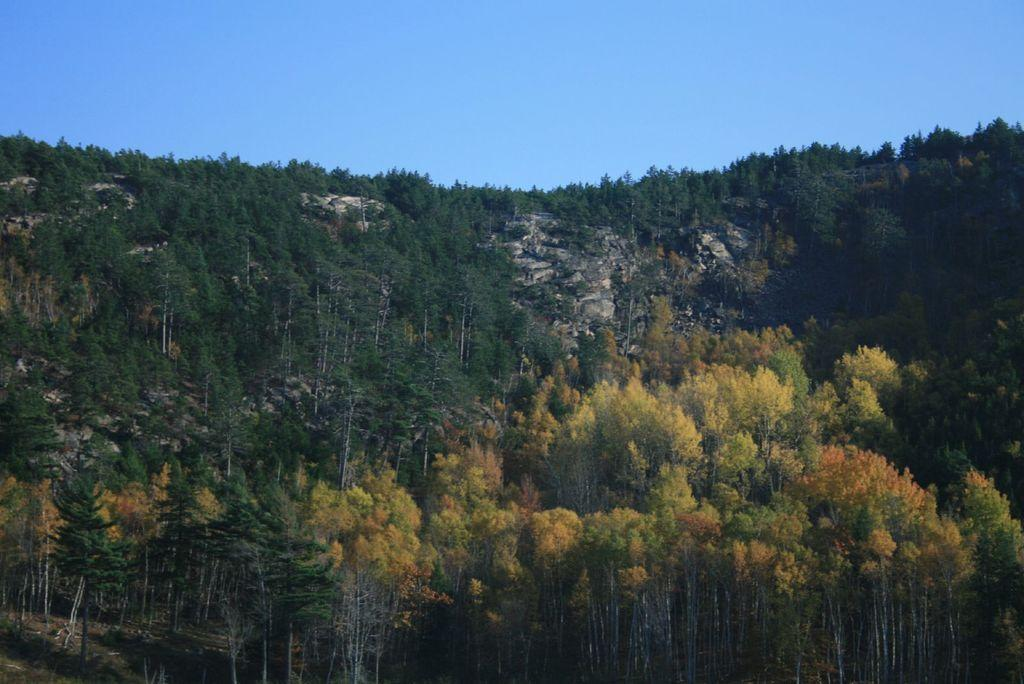What type of vegetation is present in the image? There is a group of trees in the image. What geographical feature can be seen in the image? There is a hill in the image. What is visible at the top of the image? The sky is visible at the top of the image. Can you tell me how many receipts are scattered on the hill in the image? There are no receipts present in the image; it features a group of trees and a hill. What type of power source is visible on the hill in the image? There is no power source visible on the hill in the image. 